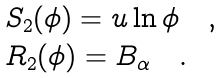Convert formula to latex. <formula><loc_0><loc_0><loc_500><loc_500>\begin{array} { l } S _ { 2 } ( \phi ) = u \ln \phi \quad , \\ R _ { 2 } ( \phi ) = B _ { \alpha } \quad . \end{array}</formula> 